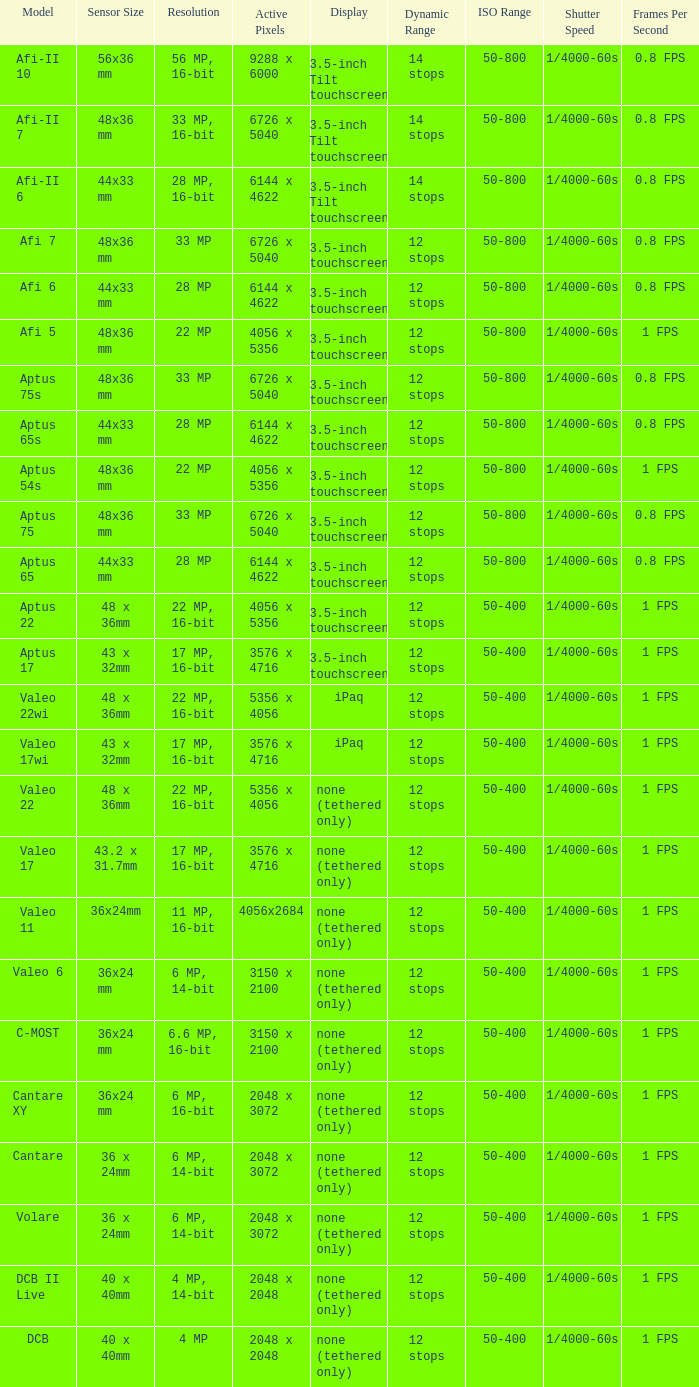Which model has a sensor sized 48x36 mm, pixels of 6726 x 5040, and a 33 mp resolution? Afi 7, Aptus 75s, Aptus 75. 